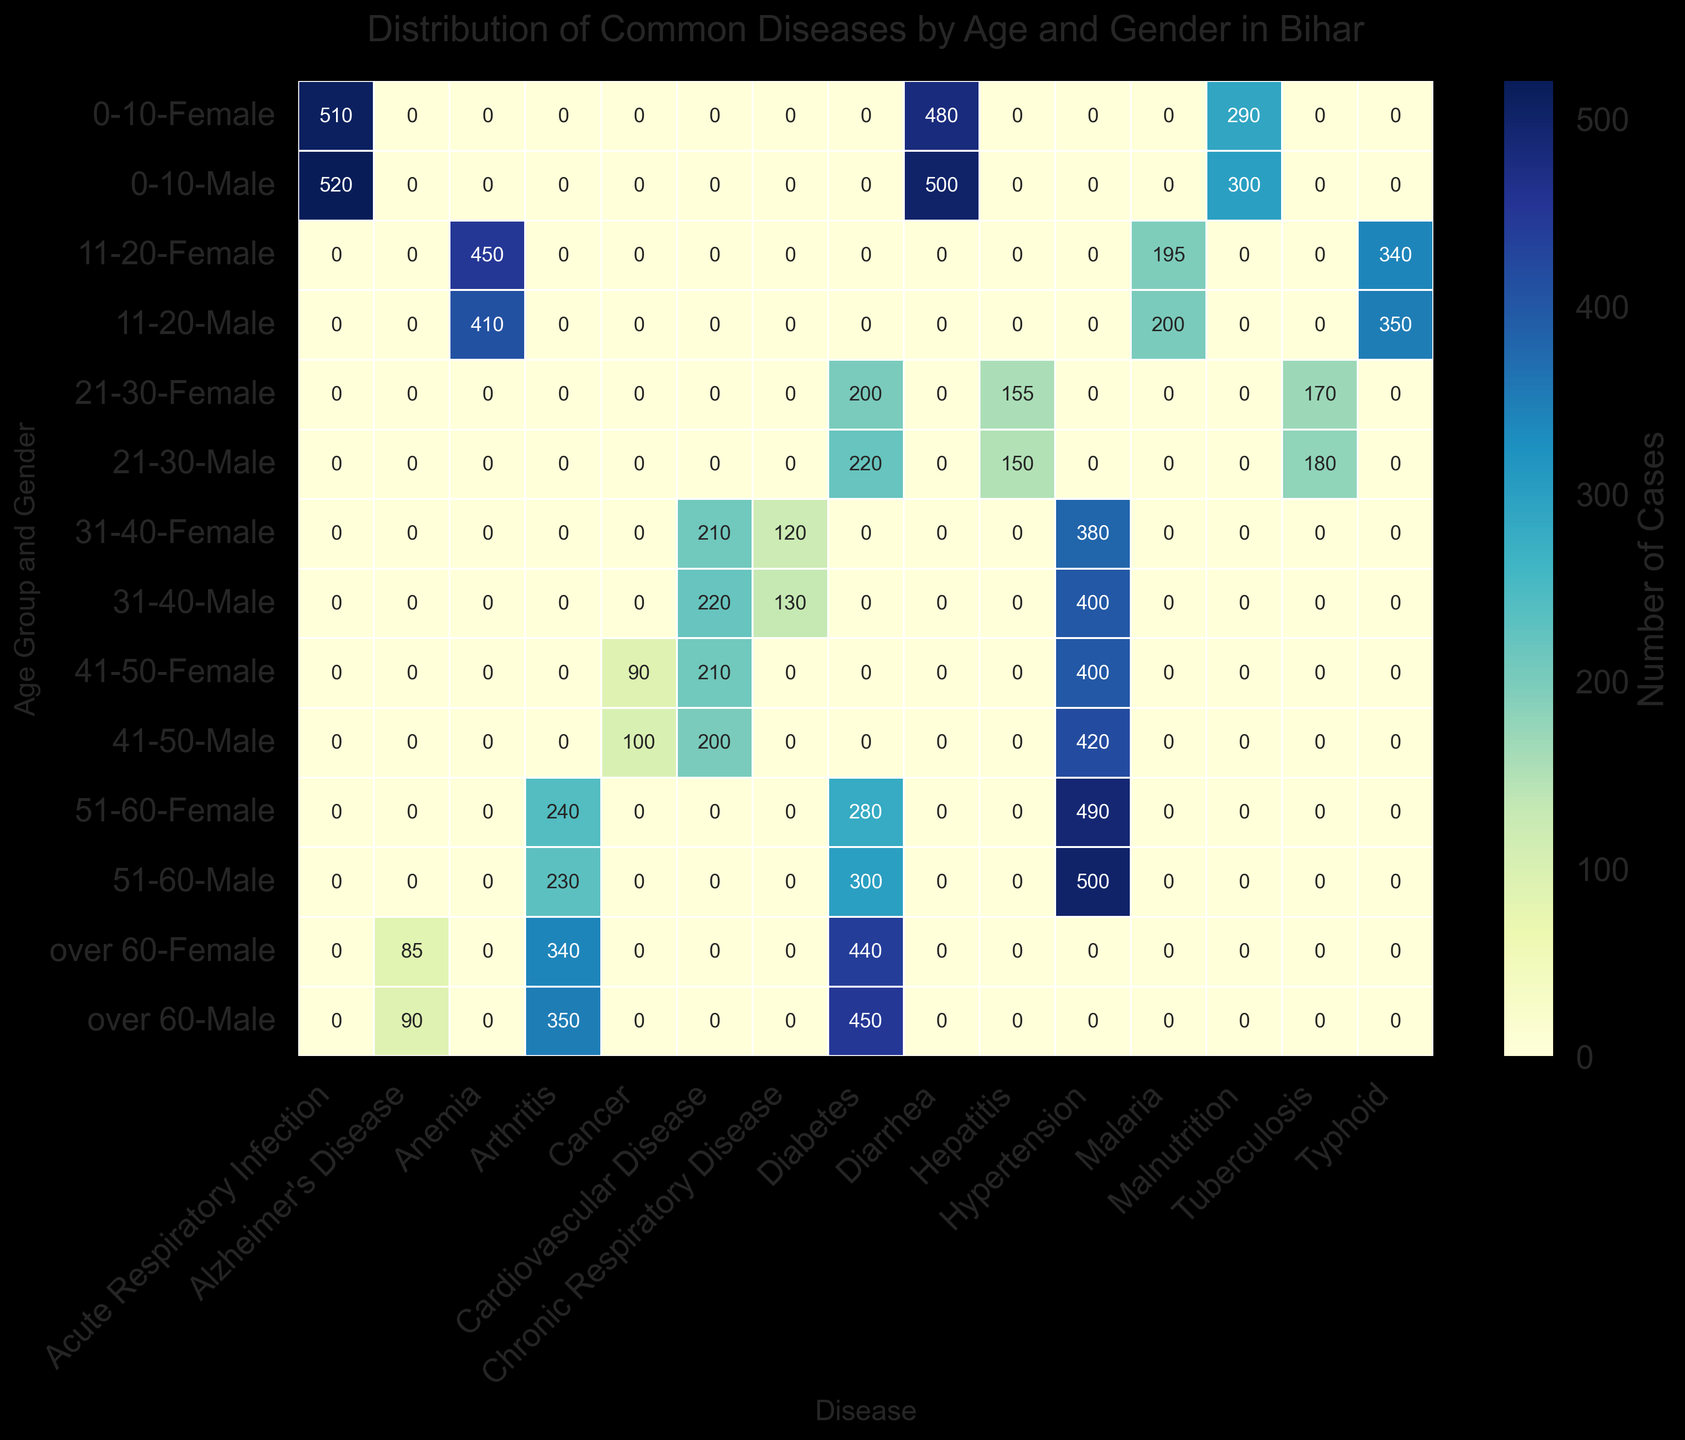What disease has the highest count for males aged 0-10? First, locate the row corresponding to the age group "0-10" and gender "Male". Then identify the disease column with the highest value in that row. The highest count is for "Acute Respiratory Infection" with 520 cases.
Answer: Acute Respiratory Infection Which gender has more Typhoid cases in the 11-20 age group? Examine the rows for the age group "11-20" for both genders. Compare the values in the "Typhoid" column. Males have 350 cases and females have 340 cases. Males have more Typhoid cases.
Answer: Male What is the total number of Hypertension cases across all age groups for males? Identify and sum the values in the "Hypertension" column for all rows where the gender is "Male". The counts are 400 (31-40), 420 (41-50), and 500 (51-60). The total is 400 + 420 + 500 = 1320.
Answer: 1320 Compare the number of Diabetes cases between the age groups 51-60 and over 60 for females. Which age group has more cases? Locate the "Diabetes" value for females in the 51-60 age group, which is 280, and compare it with the value for females over 60, which is 440. Over 60 has more cases.
Answer: Over 60 How does the number of Alzheimer's Disease cases compare between the genders over 60? Compare the "Alzheimer's Disease" row for the "over 60" age group for both genders. Males have 90 cases and females have 85 cases. Males have more cases.
Answer: Male What is the combined count of Malnutrition for both genders aged 0-10? Sum the value of "Malnutrition" for both genders in the age group 0-10. The values are 300 (Male) and 290 (Female). The combined count is 300 + 290 = 590.
Answer: 590 Which disease has the highest count for females in the age group 21-30? Look at the row for the age group "21-30" for females. The highest count in this row is in the "Diabetes" column with 200 cases.
Answer: Diabetes Identify the disease with the least count in the age group 41-50 for males. Locate the row for males aged 41-50 and find the disease column with the smallest value. This is "Cancer" with 100 cases.
Answer: Cancer What is the difference in the number of cases of Cardiovascular Disease between males and females in the age group 31-40? Identify the "Cardiovascular Disease" values for both genders in the 31-40 age group: 220 for males and 210 for females. The difference is 220 - 210 = 10.
Answer: 10 How many more cases of Anemia are there in females aged 11-20 compared to males? Check the "Anemia" column for the 11-20 age group for both genders. Females have 450 cases and males have 410 cases. The difference is 450 - 410 = 40.
Answer: 40 